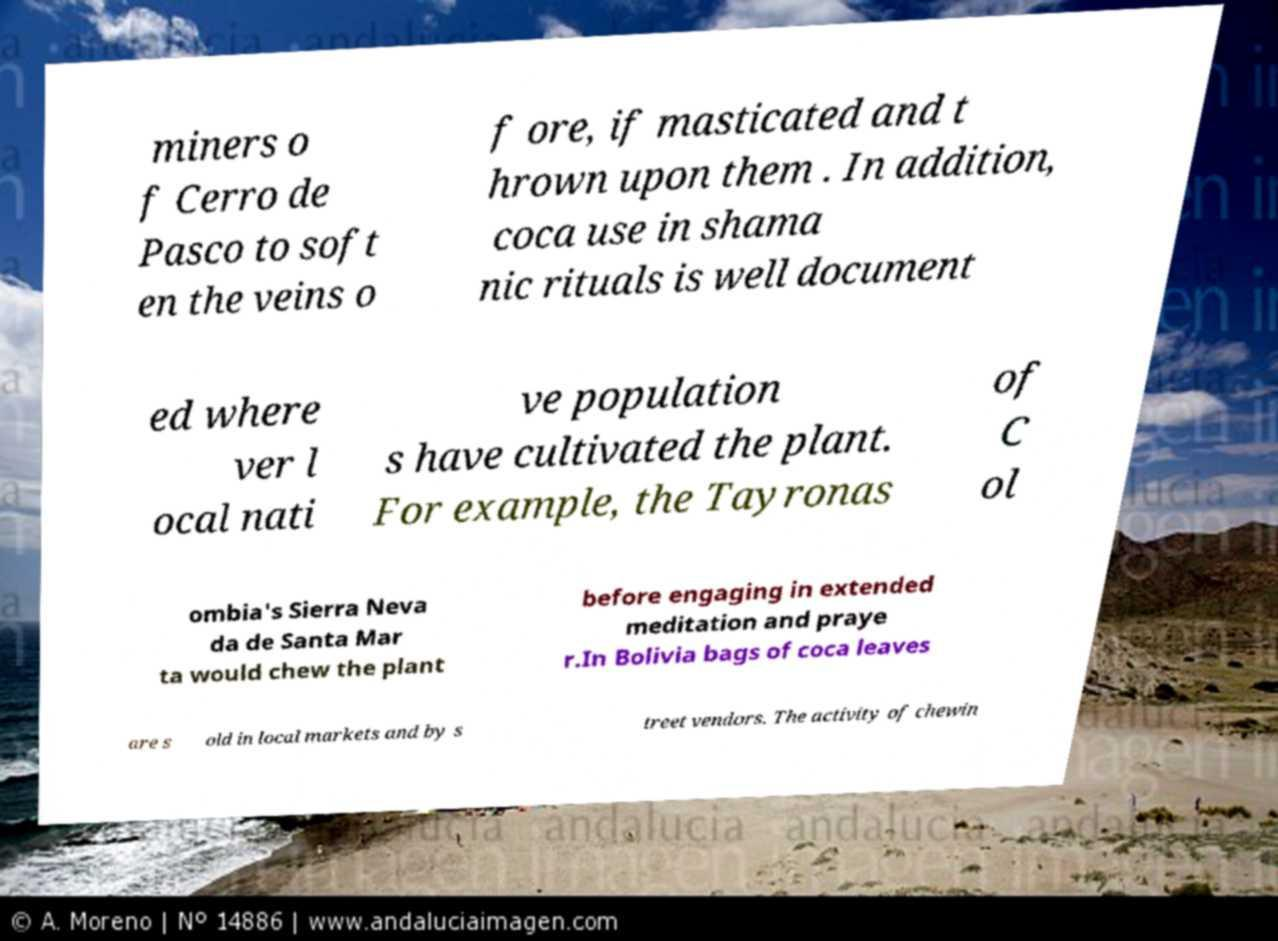For documentation purposes, I need the text within this image transcribed. Could you provide that? miners o f Cerro de Pasco to soft en the veins o f ore, if masticated and t hrown upon them . In addition, coca use in shama nic rituals is well document ed where ver l ocal nati ve population s have cultivated the plant. For example, the Tayronas of C ol ombia's Sierra Neva da de Santa Mar ta would chew the plant before engaging in extended meditation and praye r.In Bolivia bags of coca leaves are s old in local markets and by s treet vendors. The activity of chewin 